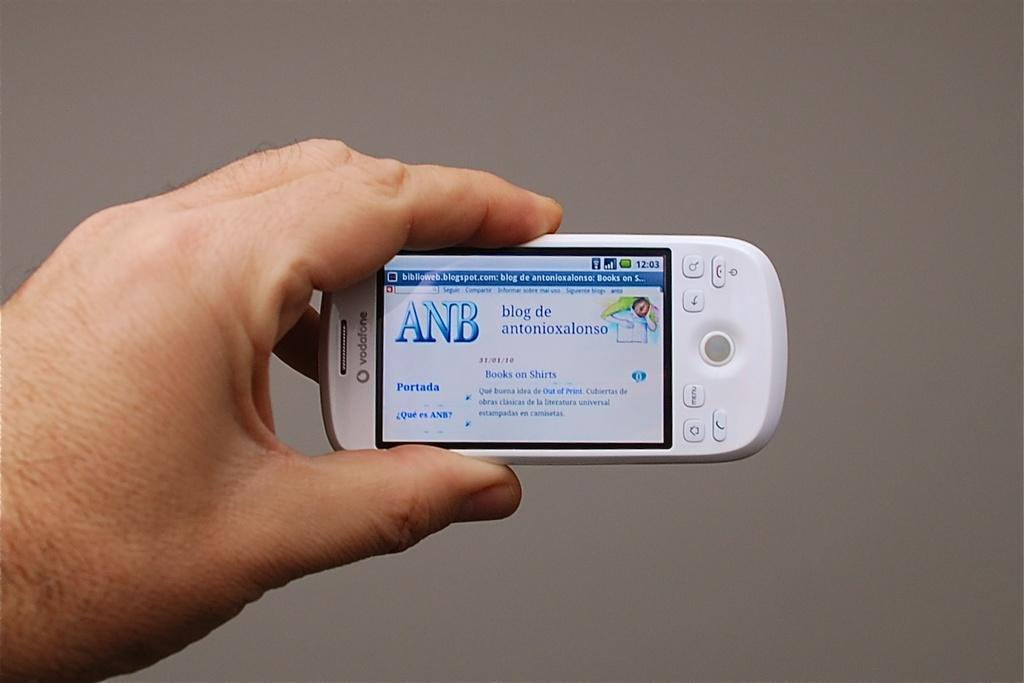<image>
Create a compact narrative representing the image presented. A hand holding a small white phone that says ANB blog de Antonioxalonso on the screen of it. 